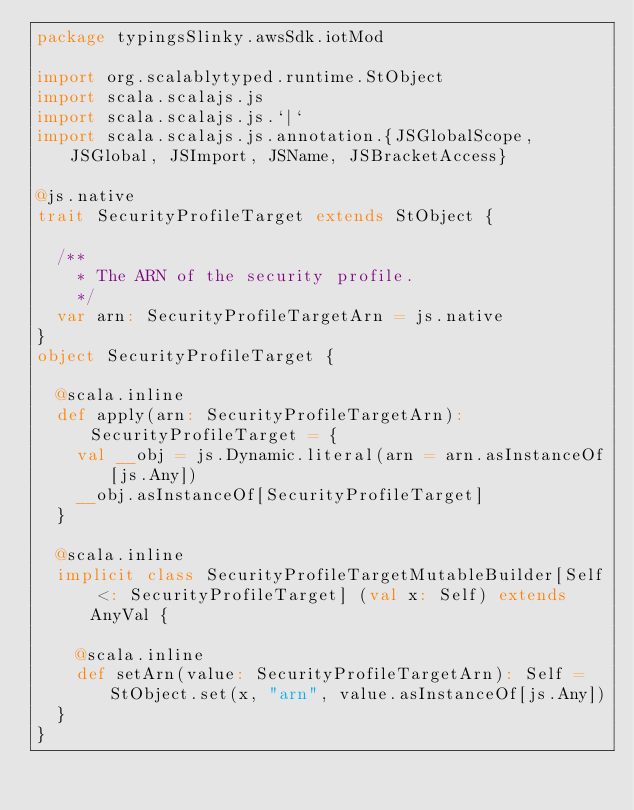Convert code to text. <code><loc_0><loc_0><loc_500><loc_500><_Scala_>package typingsSlinky.awsSdk.iotMod

import org.scalablytyped.runtime.StObject
import scala.scalajs.js
import scala.scalajs.js.`|`
import scala.scalajs.js.annotation.{JSGlobalScope, JSGlobal, JSImport, JSName, JSBracketAccess}

@js.native
trait SecurityProfileTarget extends StObject {
  
  /**
    * The ARN of the security profile.
    */
  var arn: SecurityProfileTargetArn = js.native
}
object SecurityProfileTarget {
  
  @scala.inline
  def apply(arn: SecurityProfileTargetArn): SecurityProfileTarget = {
    val __obj = js.Dynamic.literal(arn = arn.asInstanceOf[js.Any])
    __obj.asInstanceOf[SecurityProfileTarget]
  }
  
  @scala.inline
  implicit class SecurityProfileTargetMutableBuilder[Self <: SecurityProfileTarget] (val x: Self) extends AnyVal {
    
    @scala.inline
    def setArn(value: SecurityProfileTargetArn): Self = StObject.set(x, "arn", value.asInstanceOf[js.Any])
  }
}
</code> 